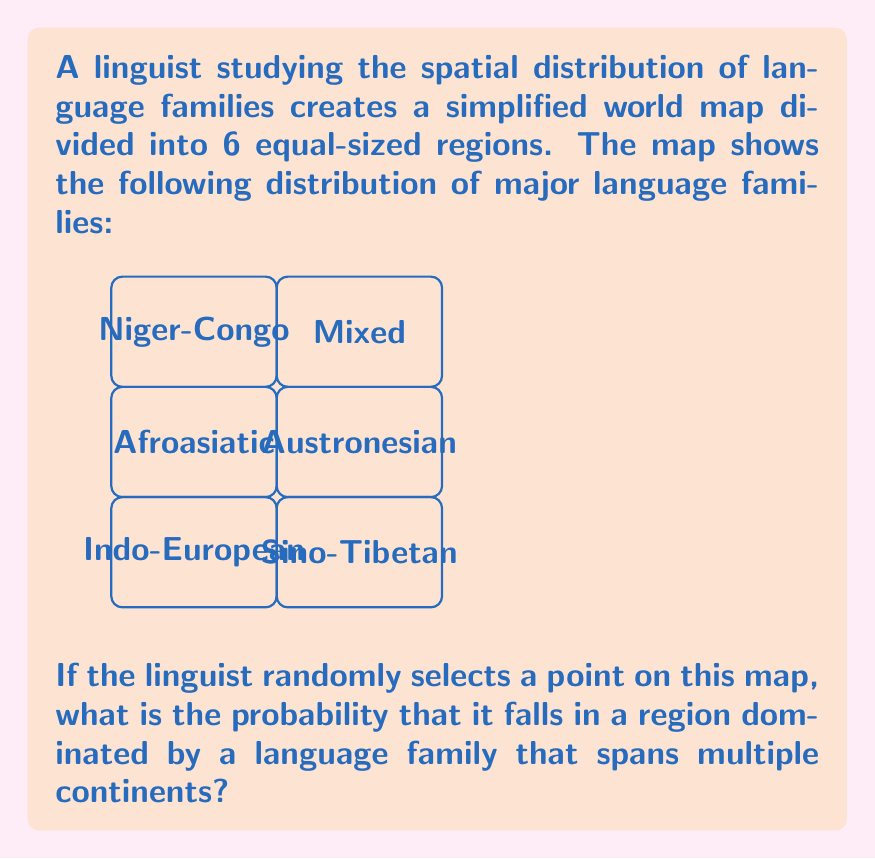Help me with this question. To solve this problem, we need to follow these steps:

1) Identify which language families span multiple continents:
   - Indo-European: spans Europe, Asia, and the Americas
   - Afroasiatic: spans Africa and Asia
   - Austronesian: spans Asia and Oceania

2) Count how many regions these families occupy:
   - Indo-European: 1 region
   - Afroasiatic: 1 region
   - Austronesian: 1 region
   Total: 3 regions

3) Calculate the probability:
   - Total number of regions: 6
   - Number of favorable regions: 3
   
   The probability is the ratio of favorable outcomes to total outcomes:

   $$P = \frac{\text{favorable outcomes}}{\text{total outcomes}} = \frac{3}{6} = \frac{1}{2}$$

Therefore, the probability of randomly selecting a point in a region dominated by a language family that spans multiple continents is $\frac{1}{2}$ or 0.5 or 50%.
Answer: $\frac{1}{2}$ 